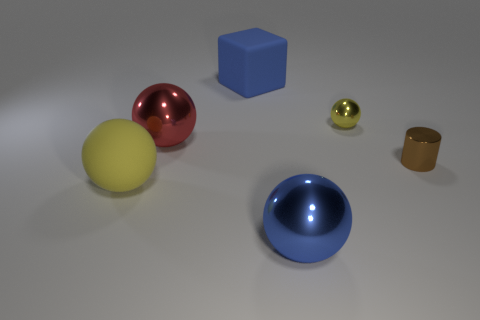Add 2 shiny balls. How many objects exist? 8 Subtract all cylinders. How many objects are left? 5 Subtract 0 blue cylinders. How many objects are left? 6 Subtract all small yellow shiny things. Subtract all yellow shiny balls. How many objects are left? 4 Add 2 big red things. How many big red things are left? 3 Add 6 large blue balls. How many large blue balls exist? 7 